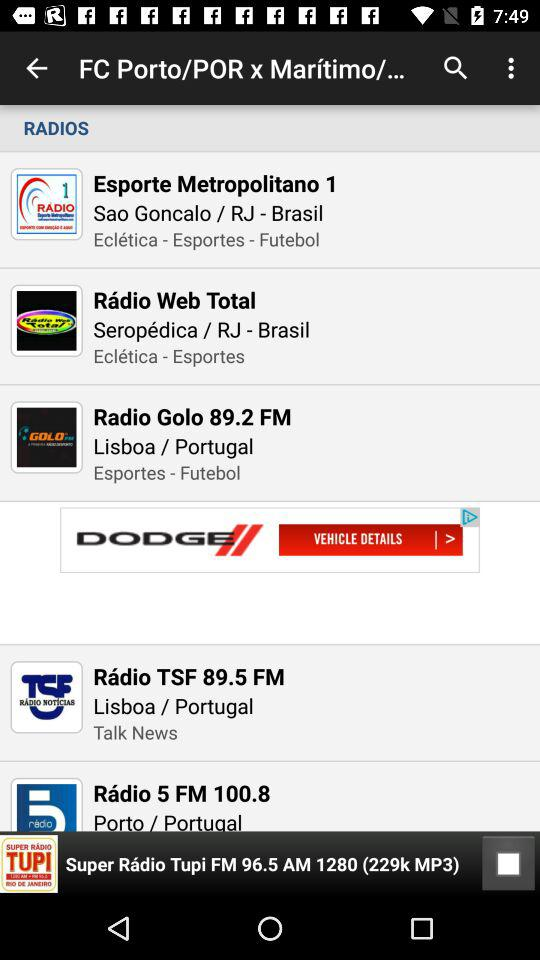What is the frequency of "Radio Golo"? The frequency of "Radio Golo" is 89.2. 